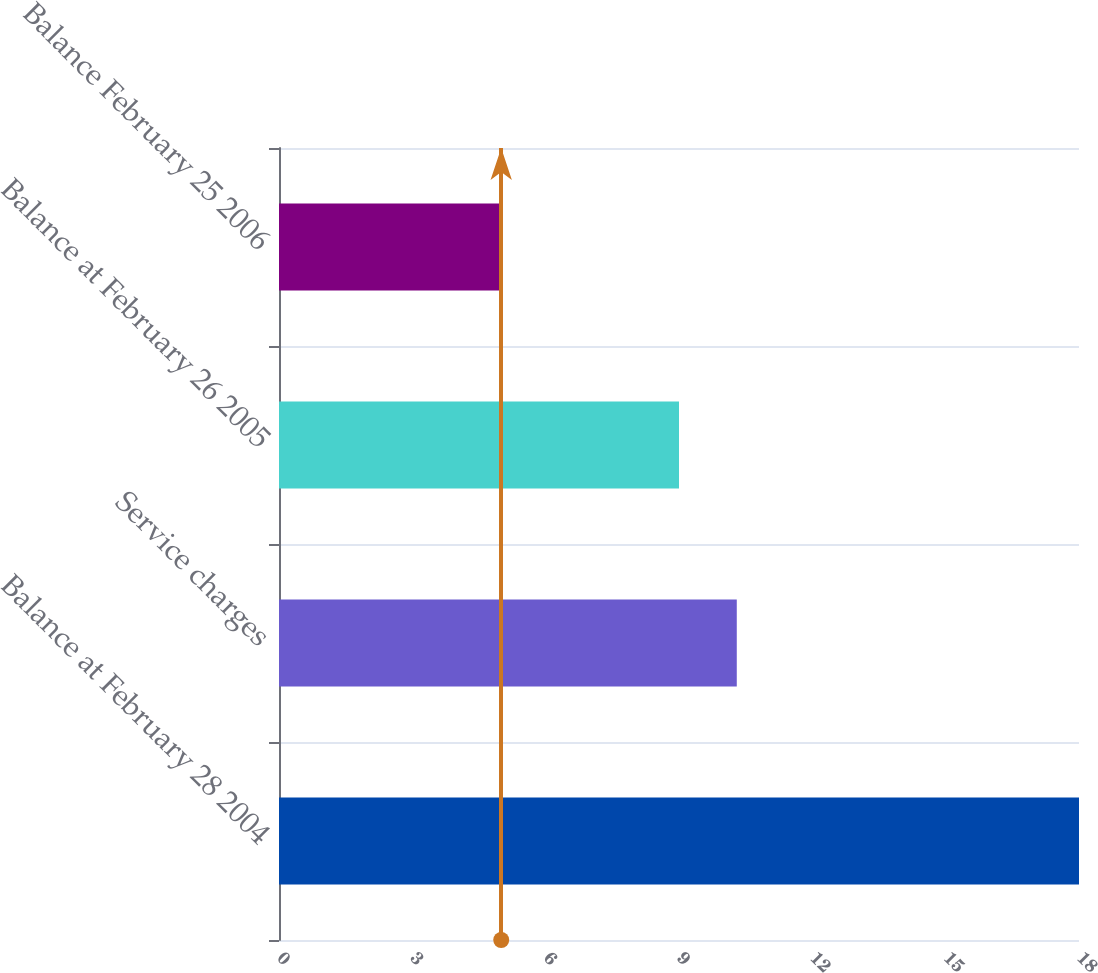Convert chart. <chart><loc_0><loc_0><loc_500><loc_500><bar_chart><fcel>Balance at February 28 2004<fcel>Service charges<fcel>Balance at February 26 2005<fcel>Balance February 25 2006<nl><fcel>18<fcel>10.3<fcel>9<fcel>5<nl></chart> 